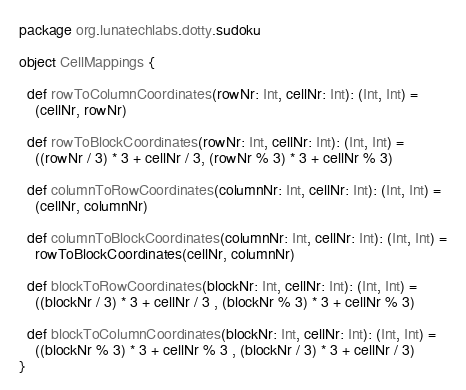<code> <loc_0><loc_0><loc_500><loc_500><_Scala_>package org.lunatechlabs.dotty.sudoku

object CellMappings {

  def rowToColumnCoordinates(rowNr: Int, cellNr: Int): (Int, Int) =
    (cellNr, rowNr)

  def rowToBlockCoordinates(rowNr: Int, cellNr: Int): (Int, Int) =
    ((rowNr / 3) * 3 + cellNr / 3, (rowNr % 3) * 3 + cellNr % 3)

  def columnToRowCoordinates(columnNr: Int, cellNr: Int): (Int, Int) =
    (cellNr, columnNr)

  def columnToBlockCoordinates(columnNr: Int, cellNr: Int): (Int, Int) =
    rowToBlockCoordinates(cellNr, columnNr)

  def blockToRowCoordinates(blockNr: Int, cellNr: Int): (Int, Int) =
    ((blockNr / 3) * 3 + cellNr / 3 , (blockNr % 3) * 3 + cellNr % 3)

  def blockToColumnCoordinates(blockNr: Int, cellNr: Int): (Int, Int) =
    ((blockNr % 3) * 3 + cellNr % 3 , (blockNr / 3) * 3 + cellNr / 3)
}
</code> 